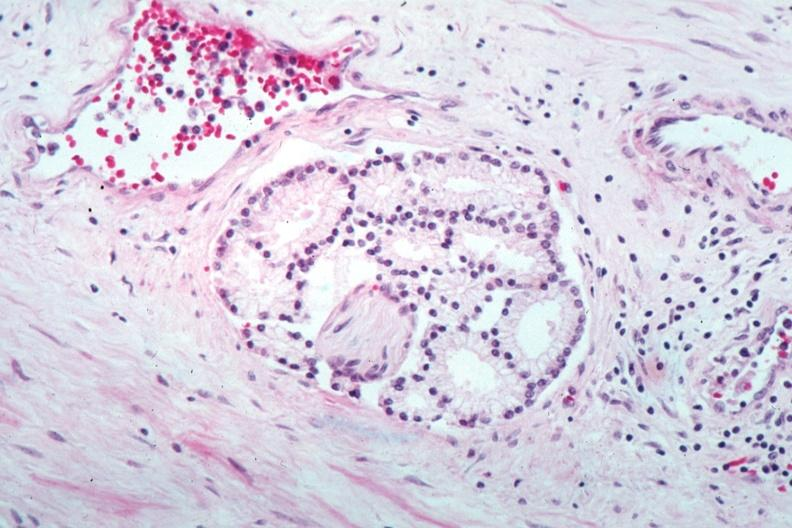what is present?
Answer the question using a single word or phrase. Adenocarcinoma 